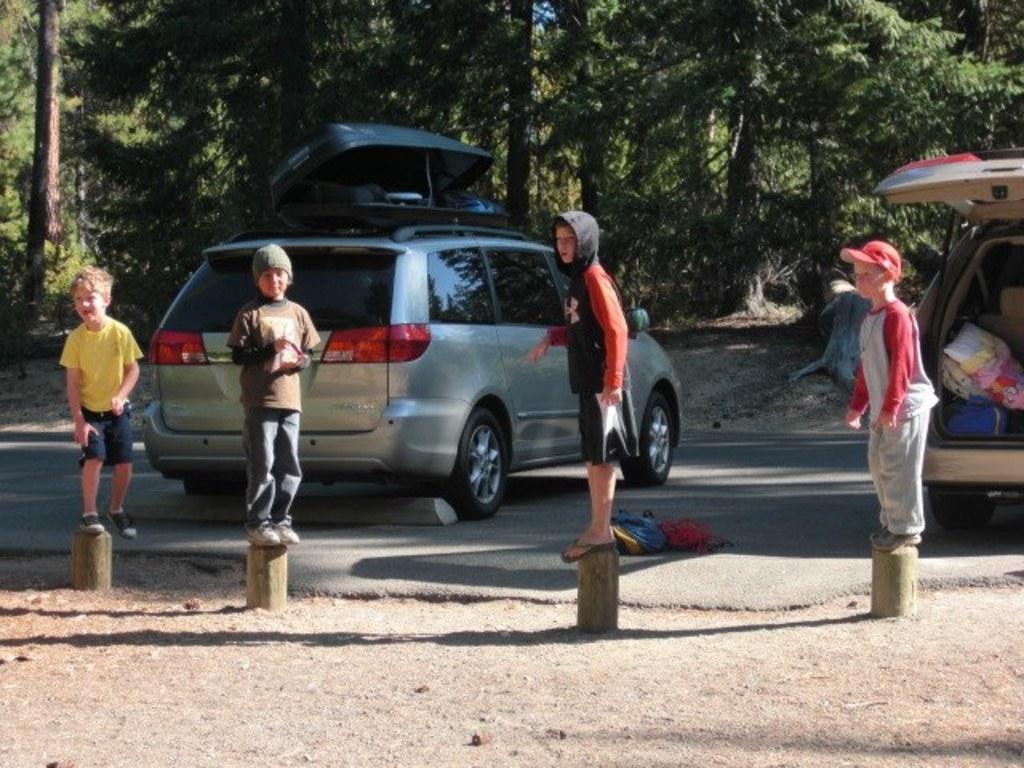Please provide a concise description of this image. In this image we can see few children standing on the object and there are two vehicles on the road and we can see some objects. There are some trees in the background. 